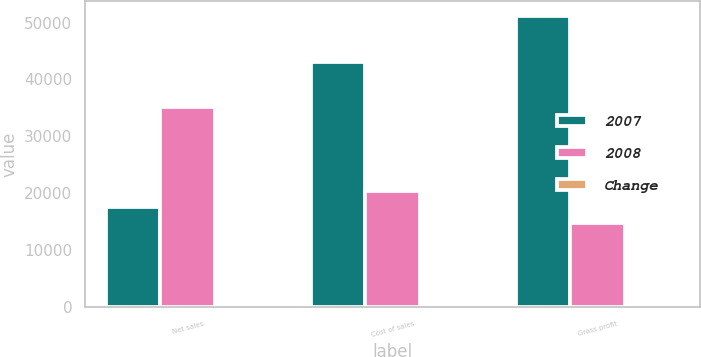Convert chart to OTSL. <chart><loc_0><loc_0><loc_500><loc_500><stacked_bar_chart><ecel><fcel>Net sales<fcel>Cost of sales<fcel>Gross profit<nl><fcel>2007<fcel>17622.5<fcel>43059<fcel>51183<nl><fcel>2008<fcel>35245<fcel>20379<fcel>14866<nl><fcel>Change<fcel>167.4<fcel>111.3<fcel>244.3<nl></chart> 